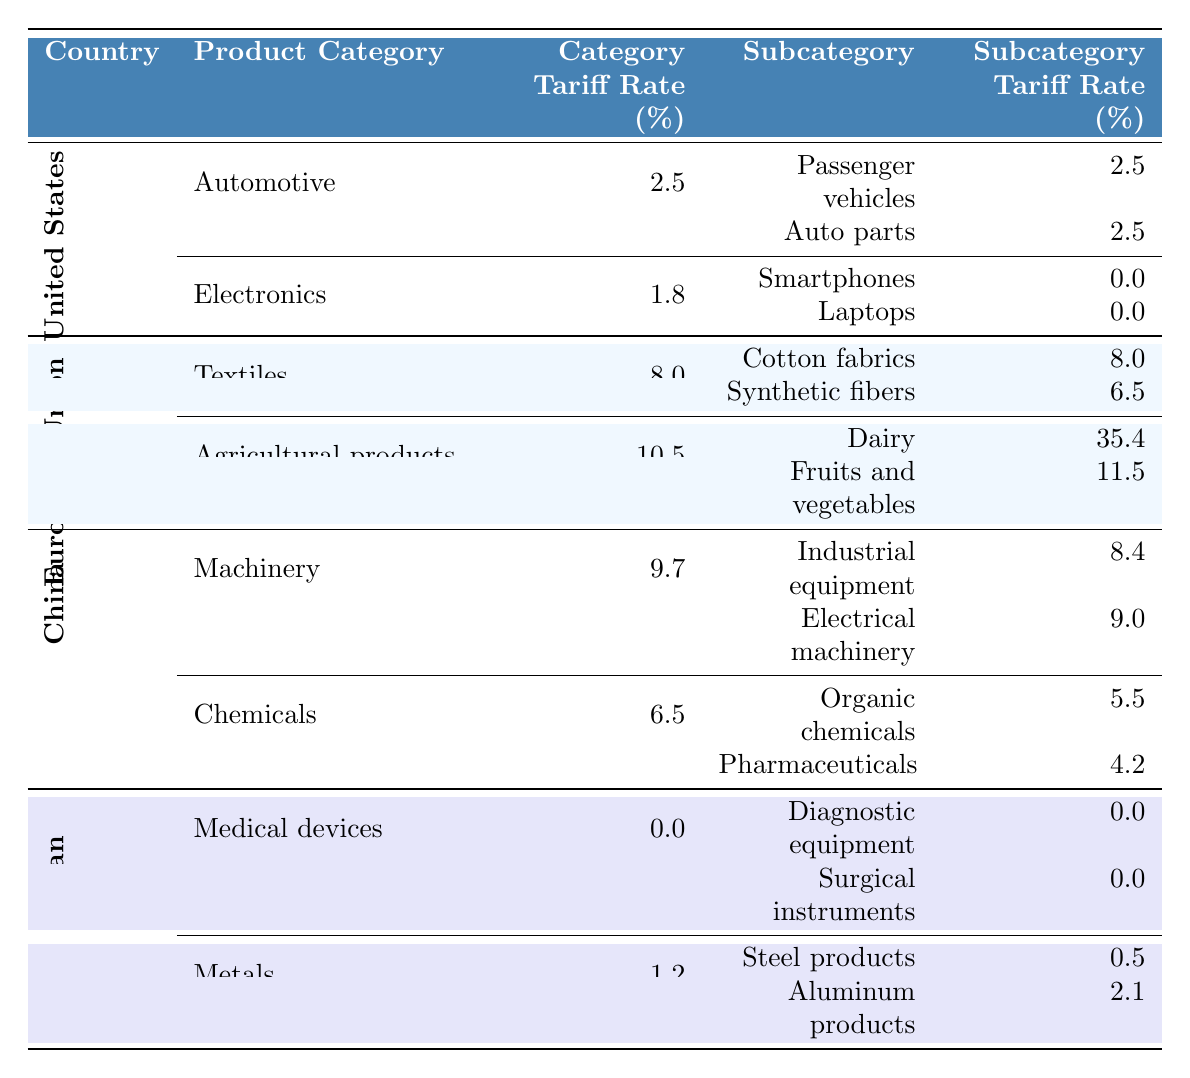What is the tariff rate on passenger vehicles in the United States? The table shows that the tariff rate for passenger vehicles under the automotive category in the United States is 2.5%.
Answer: 2.5% Which country has the highest tariff rate on dairy products? According to the table, the European Union has the highest tariff rate on dairy products at 35.4%.
Answer: European Union What is the average tariff rate for subcategories under the electronic product category in the United States? For the electronics category in the United States, there are two subcategories: smartphones (0%) and laptops (0%). The average is (0 + 0) / 2 = 0%.
Answer: 0% Is there any country that has a 0% tariff rate for medical devices? The table indicates that Japan has a 0% tariff rate for all medical device subcategories, including diagnostic equipment and surgical instruments.
Answer: Yes Which product category has the lowest overall tariff rate in the table? The tariffs for medical devices in Japan are 0%, and also the electronics category in the United States has a low rate of 1.8%. Comparing these, the medical devices category has the lowest overall tariff rate of 0%.
Answer: Medical devices What is the combined tariff rate for all subcategories under the machinery category in China? The machinery category in China has subcategories with tariff rates of 8.4% for industrial equipment and 9.0% for electrical machinery. The sum is 8.4% + 9.0% = 17.4%.
Answer: 17.4% Identify which country has a higher tariff rate on synthetic fibers compared to its general textiles tariff rate. The European Union has a general textiles tariff rate of 8% and a specific tariff rate of 6.5% for synthetic fibers, which is lower than the general rate. Thus, no country has a higher rate for synthetic fibers than their overall textiles rate based on the table.
Answer: No Are there any subcategories under the chemicals category in China that have a lower tariff rate than the category's overall rate? The overall tariff rate for chemicals in China is 6.5%, while the subcategories have rates of 5.5% (organic chemicals) and 4.2% (pharmaceuticals), both of which are lower than the category rate.
Answer: Yes What is the total tariff rate for agricultural products in the European Union? The table shows that agricultural products have a general tariff rate of 10.5%, which means all agricultural product categories within the EU are subject to this specific rate.
Answer: 10.5% Which country has more diverse product categories in terms of subcategories listed? The United States has two product categories each with two subcategories, whereas the European Union and China each have two categories with more detailed subcategories. However, the EU has the most detailed rates; thus, considering distinct counts, the U.S. has more variety in categories with consistent subcategories.
Answer: United States 